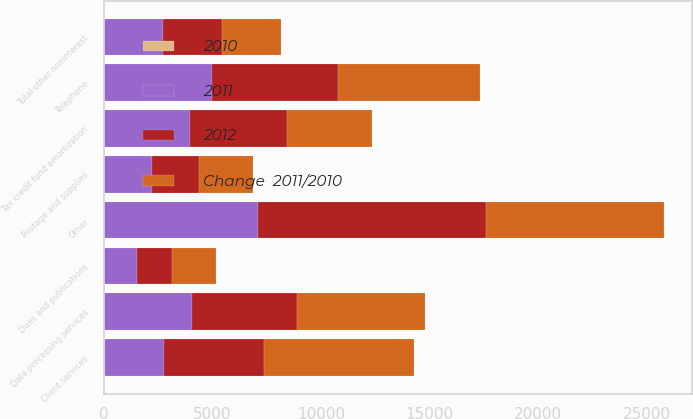Convert chart. <chart><loc_0><loc_0><loc_500><loc_500><stacked_bar_chart><ecel><fcel>Telephone<fcel>Client services<fcel>Data processing services<fcel>Tax credit fund amortization<fcel>Postage and supplies<fcel>Dues and publications<fcel>Other<fcel>Total other noninterest<nl><fcel>Change  2011/2010<fcel>6528<fcel>6910<fcel>5876<fcel>3911<fcel>2482<fcel>2067<fcel>8188<fcel>2716<nl><fcel>2012<fcel>5835<fcel>4594<fcel>4811<fcel>4474<fcel>2162<fcel>1570<fcel>10499<fcel>2716<nl><fcel>2010<fcel>11.9<fcel>50.4<fcel>22.1<fcel>12.6<fcel>14.8<fcel>31.7<fcel>22<fcel>16.7<nl><fcel>2011<fcel>4952<fcel>2716<fcel>4060<fcel>3965<fcel>2198<fcel>1519<fcel>7081<fcel>2716<nl></chart> 